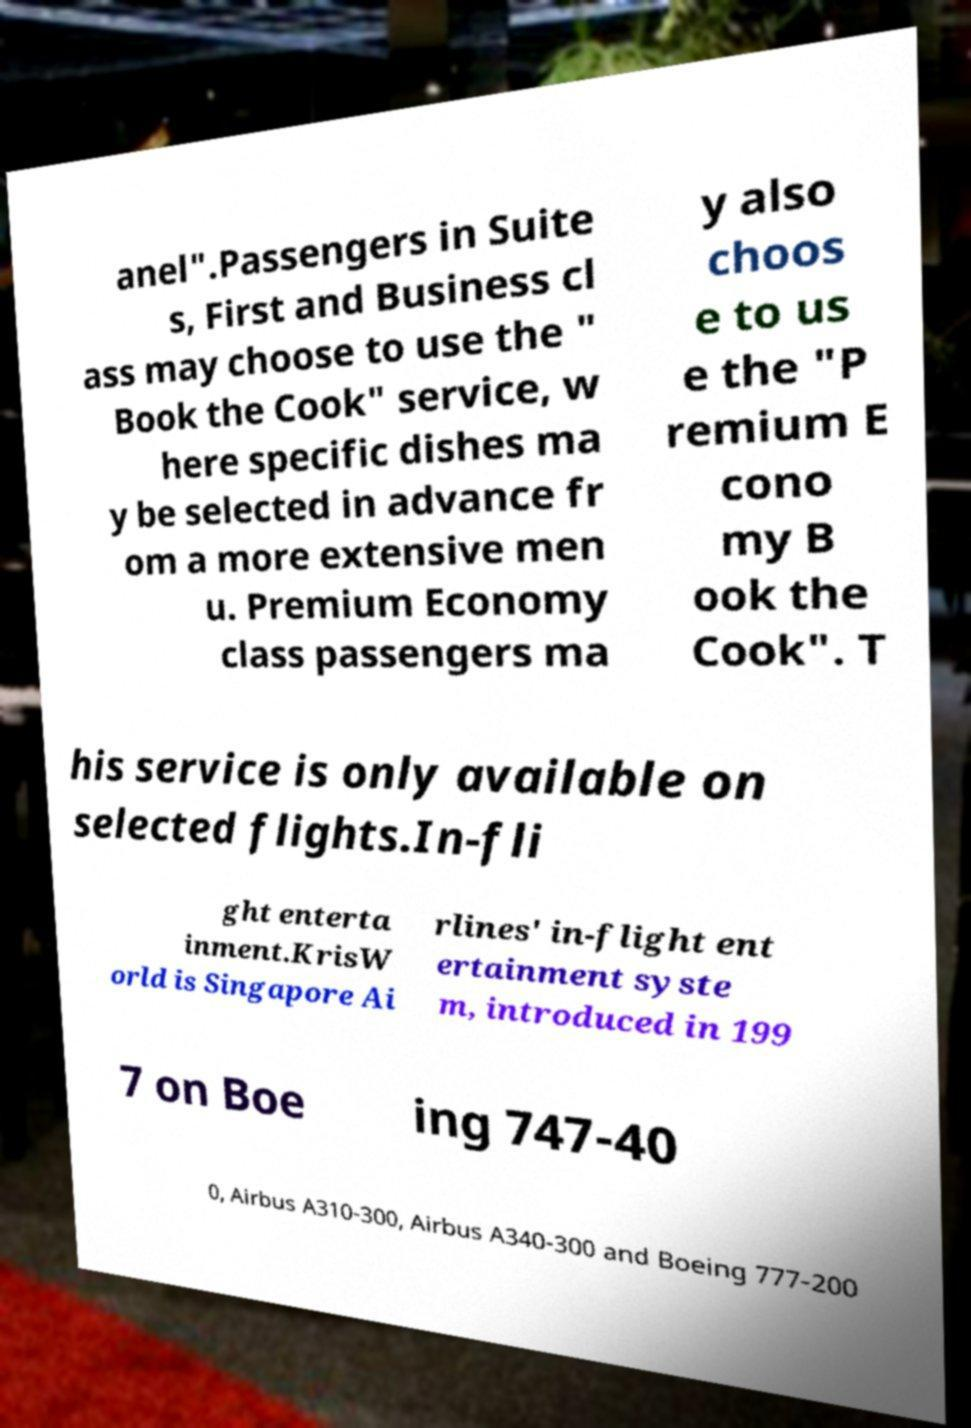Could you extract and type out the text from this image? anel".Passengers in Suite s, First and Business cl ass may choose to use the " Book the Cook" service, w here specific dishes ma y be selected in advance fr om a more extensive men u. Premium Economy class passengers ma y also choos e to us e the "P remium E cono my B ook the Cook". T his service is only available on selected flights.In-fli ght enterta inment.KrisW orld is Singapore Ai rlines' in-flight ent ertainment syste m, introduced in 199 7 on Boe ing 747-40 0, Airbus A310-300, Airbus A340-300 and Boeing 777-200 